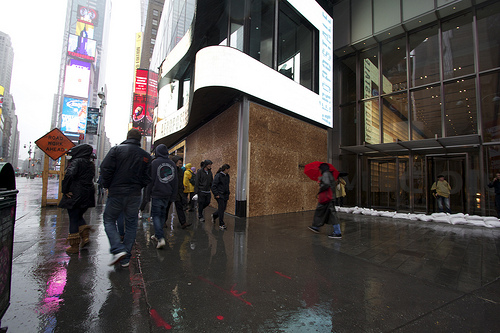<image>
Is the umbrella behind the sign? No. The umbrella is not behind the sign. From this viewpoint, the umbrella appears to be positioned elsewhere in the scene. 